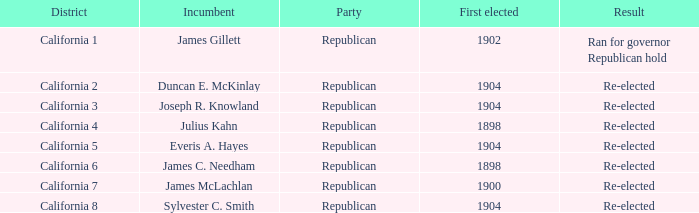What is the highest initial election result that led to re-election in california's 5th district? 1904.0. 